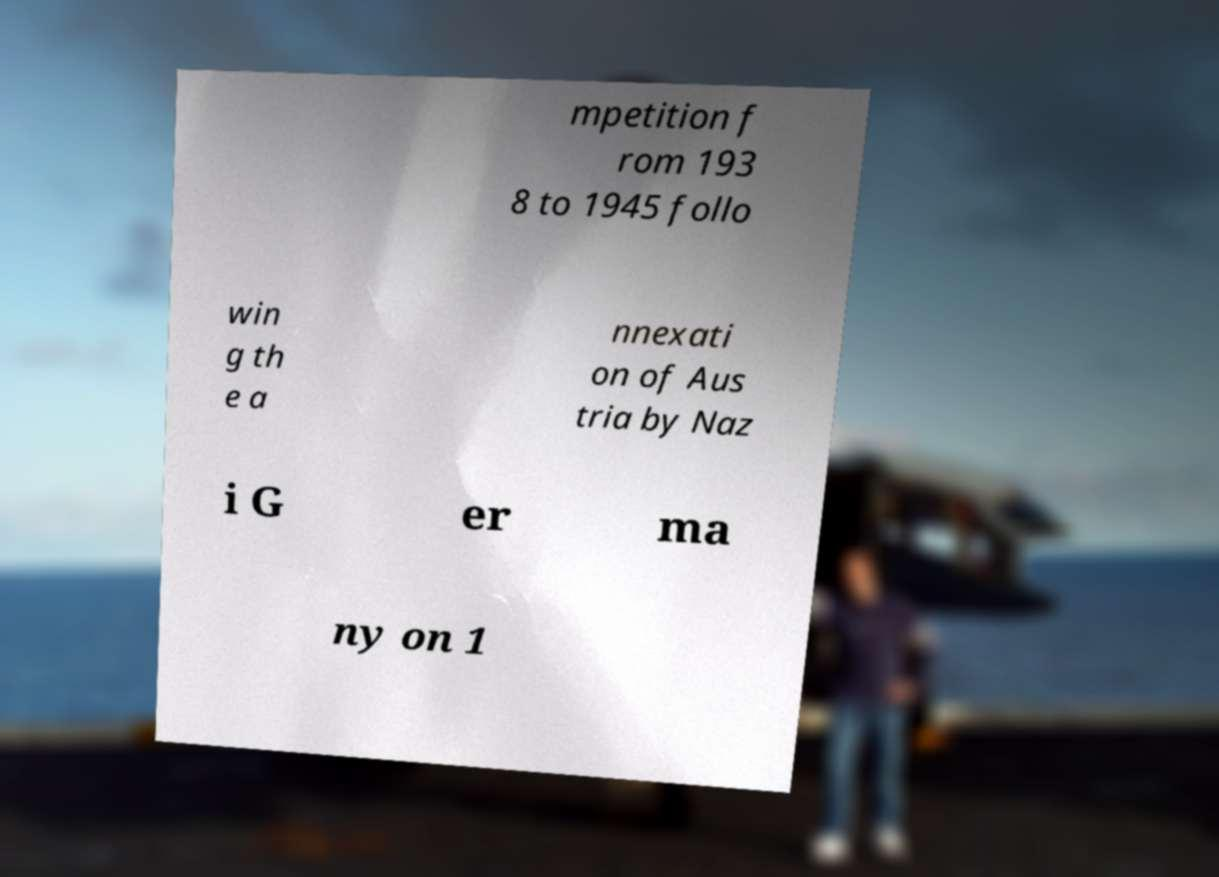Can you read and provide the text displayed in the image?This photo seems to have some interesting text. Can you extract and type it out for me? mpetition f rom 193 8 to 1945 follo win g th e a nnexati on of Aus tria by Naz i G er ma ny on 1 